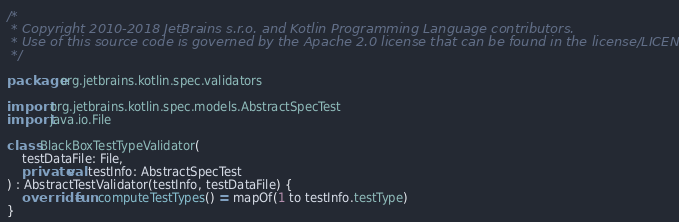Convert code to text. <code><loc_0><loc_0><loc_500><loc_500><_Kotlin_>/*
 * Copyright 2010-2018 JetBrains s.r.o. and Kotlin Programming Language contributors.
 * Use of this source code is governed by the Apache 2.0 license that can be found in the license/LICENSE.txt file.
 */

package org.jetbrains.kotlin.spec.validators

import org.jetbrains.kotlin.spec.models.AbstractSpecTest
import java.io.File

class BlackBoxTestTypeValidator(
    testDataFile: File,
    private val testInfo: AbstractSpecTest
) : AbstractTestValidator(testInfo, testDataFile) {
    override fun computeTestTypes() = mapOf(1 to testInfo.testType)
}
</code> 